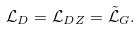<formula> <loc_0><loc_0><loc_500><loc_500>\mathcal { L } _ { D } = \mathcal { L } _ { D Z } = \mathcal { \tilde { L } } _ { G } .</formula> 